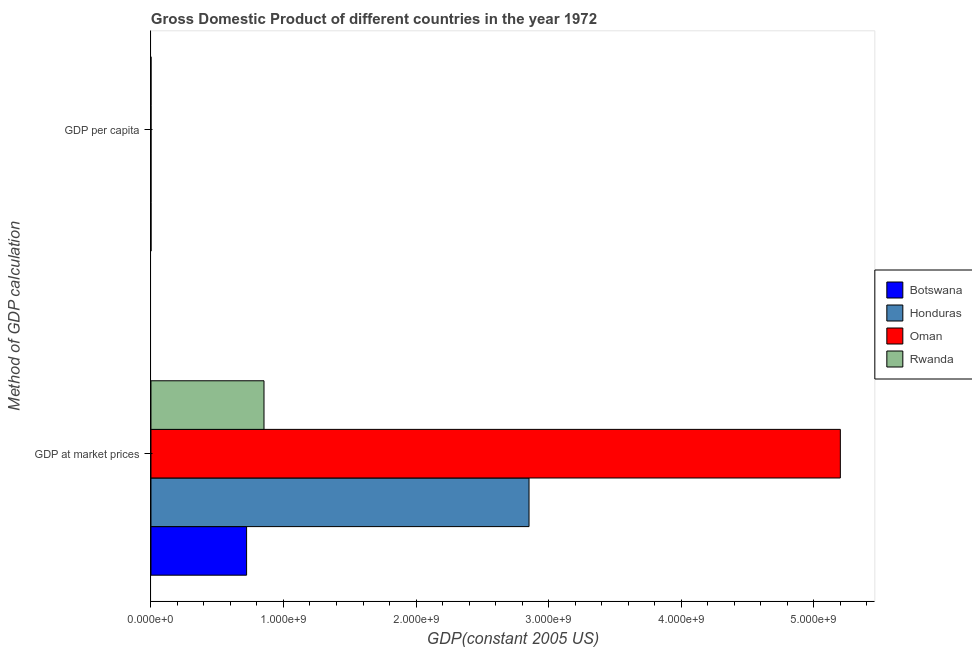How many groups of bars are there?
Offer a terse response. 2. How many bars are there on the 2nd tick from the top?
Provide a succinct answer. 4. How many bars are there on the 2nd tick from the bottom?
Keep it short and to the point. 4. What is the label of the 1st group of bars from the top?
Keep it short and to the point. GDP per capita. What is the gdp per capita in Rwanda?
Keep it short and to the point. 214.11. Across all countries, what is the maximum gdp per capita?
Offer a terse response. 6700.51. Across all countries, what is the minimum gdp at market prices?
Provide a short and direct response. 7.22e+08. In which country was the gdp at market prices maximum?
Keep it short and to the point. Oman. In which country was the gdp at market prices minimum?
Your answer should be compact. Botswana. What is the total gdp per capita in the graph?
Your response must be concise. 8892.82. What is the difference between the gdp per capita in Oman and that in Botswana?
Give a very brief answer. 5724.99. What is the difference between the gdp at market prices in Rwanda and the gdp per capita in Botswana?
Keep it short and to the point. 8.53e+08. What is the average gdp at market prices per country?
Keep it short and to the point. 2.41e+09. What is the difference between the gdp per capita and gdp at market prices in Rwanda?
Offer a terse response. -8.53e+08. What is the ratio of the gdp at market prices in Botswana to that in Honduras?
Provide a succinct answer. 0.25. What does the 1st bar from the top in GDP per capita represents?
Ensure brevity in your answer.  Rwanda. What does the 3rd bar from the bottom in GDP at market prices represents?
Offer a very short reply. Oman. How many bars are there?
Provide a succinct answer. 8. How many countries are there in the graph?
Your answer should be very brief. 4. What is the difference between two consecutive major ticks on the X-axis?
Ensure brevity in your answer.  1.00e+09. Does the graph contain any zero values?
Provide a succinct answer. No. Does the graph contain grids?
Your answer should be very brief. No. Where does the legend appear in the graph?
Provide a short and direct response. Center right. What is the title of the graph?
Offer a very short reply. Gross Domestic Product of different countries in the year 1972. What is the label or title of the X-axis?
Ensure brevity in your answer.  GDP(constant 2005 US). What is the label or title of the Y-axis?
Your response must be concise. Method of GDP calculation. What is the GDP(constant 2005 US) in Botswana in GDP at market prices?
Offer a very short reply. 7.22e+08. What is the GDP(constant 2005 US) of Honduras in GDP at market prices?
Provide a short and direct response. 2.85e+09. What is the GDP(constant 2005 US) of Oman in GDP at market prices?
Ensure brevity in your answer.  5.20e+09. What is the GDP(constant 2005 US) in Rwanda in GDP at market prices?
Your answer should be very brief. 8.53e+08. What is the GDP(constant 2005 US) in Botswana in GDP per capita?
Your response must be concise. 975.53. What is the GDP(constant 2005 US) in Honduras in GDP per capita?
Make the answer very short. 1002.68. What is the GDP(constant 2005 US) of Oman in GDP per capita?
Make the answer very short. 6700.51. What is the GDP(constant 2005 US) in Rwanda in GDP per capita?
Make the answer very short. 214.11. Across all Method of GDP calculation, what is the maximum GDP(constant 2005 US) of Botswana?
Your response must be concise. 7.22e+08. Across all Method of GDP calculation, what is the maximum GDP(constant 2005 US) of Honduras?
Your response must be concise. 2.85e+09. Across all Method of GDP calculation, what is the maximum GDP(constant 2005 US) in Oman?
Your answer should be compact. 5.20e+09. Across all Method of GDP calculation, what is the maximum GDP(constant 2005 US) in Rwanda?
Make the answer very short. 8.53e+08. Across all Method of GDP calculation, what is the minimum GDP(constant 2005 US) in Botswana?
Your response must be concise. 975.53. Across all Method of GDP calculation, what is the minimum GDP(constant 2005 US) in Honduras?
Your answer should be very brief. 1002.68. Across all Method of GDP calculation, what is the minimum GDP(constant 2005 US) in Oman?
Ensure brevity in your answer.  6700.51. Across all Method of GDP calculation, what is the minimum GDP(constant 2005 US) in Rwanda?
Provide a short and direct response. 214.11. What is the total GDP(constant 2005 US) of Botswana in the graph?
Give a very brief answer. 7.22e+08. What is the total GDP(constant 2005 US) of Honduras in the graph?
Ensure brevity in your answer.  2.85e+09. What is the total GDP(constant 2005 US) of Oman in the graph?
Make the answer very short. 5.20e+09. What is the total GDP(constant 2005 US) in Rwanda in the graph?
Your answer should be compact. 8.53e+08. What is the difference between the GDP(constant 2005 US) of Botswana in GDP at market prices and that in GDP per capita?
Your answer should be compact. 7.22e+08. What is the difference between the GDP(constant 2005 US) in Honduras in GDP at market prices and that in GDP per capita?
Give a very brief answer. 2.85e+09. What is the difference between the GDP(constant 2005 US) of Oman in GDP at market prices and that in GDP per capita?
Provide a short and direct response. 5.20e+09. What is the difference between the GDP(constant 2005 US) of Rwanda in GDP at market prices and that in GDP per capita?
Keep it short and to the point. 8.53e+08. What is the difference between the GDP(constant 2005 US) in Botswana in GDP at market prices and the GDP(constant 2005 US) in Honduras in GDP per capita?
Your answer should be compact. 7.22e+08. What is the difference between the GDP(constant 2005 US) of Botswana in GDP at market prices and the GDP(constant 2005 US) of Oman in GDP per capita?
Keep it short and to the point. 7.22e+08. What is the difference between the GDP(constant 2005 US) in Botswana in GDP at market prices and the GDP(constant 2005 US) in Rwanda in GDP per capita?
Give a very brief answer. 7.22e+08. What is the difference between the GDP(constant 2005 US) of Honduras in GDP at market prices and the GDP(constant 2005 US) of Oman in GDP per capita?
Offer a terse response. 2.85e+09. What is the difference between the GDP(constant 2005 US) of Honduras in GDP at market prices and the GDP(constant 2005 US) of Rwanda in GDP per capita?
Offer a very short reply. 2.85e+09. What is the difference between the GDP(constant 2005 US) of Oman in GDP at market prices and the GDP(constant 2005 US) of Rwanda in GDP per capita?
Your response must be concise. 5.20e+09. What is the average GDP(constant 2005 US) of Botswana per Method of GDP calculation?
Offer a terse response. 3.61e+08. What is the average GDP(constant 2005 US) in Honduras per Method of GDP calculation?
Your response must be concise. 1.43e+09. What is the average GDP(constant 2005 US) of Oman per Method of GDP calculation?
Offer a very short reply. 2.60e+09. What is the average GDP(constant 2005 US) in Rwanda per Method of GDP calculation?
Your answer should be compact. 4.26e+08. What is the difference between the GDP(constant 2005 US) of Botswana and GDP(constant 2005 US) of Honduras in GDP at market prices?
Make the answer very short. -2.13e+09. What is the difference between the GDP(constant 2005 US) of Botswana and GDP(constant 2005 US) of Oman in GDP at market prices?
Your answer should be compact. -4.48e+09. What is the difference between the GDP(constant 2005 US) in Botswana and GDP(constant 2005 US) in Rwanda in GDP at market prices?
Ensure brevity in your answer.  -1.31e+08. What is the difference between the GDP(constant 2005 US) of Honduras and GDP(constant 2005 US) of Oman in GDP at market prices?
Offer a terse response. -2.35e+09. What is the difference between the GDP(constant 2005 US) of Honduras and GDP(constant 2005 US) of Rwanda in GDP at market prices?
Provide a short and direct response. 2.00e+09. What is the difference between the GDP(constant 2005 US) in Oman and GDP(constant 2005 US) in Rwanda in GDP at market prices?
Make the answer very short. 4.35e+09. What is the difference between the GDP(constant 2005 US) in Botswana and GDP(constant 2005 US) in Honduras in GDP per capita?
Provide a short and direct response. -27.15. What is the difference between the GDP(constant 2005 US) in Botswana and GDP(constant 2005 US) in Oman in GDP per capita?
Your response must be concise. -5724.99. What is the difference between the GDP(constant 2005 US) of Botswana and GDP(constant 2005 US) of Rwanda in GDP per capita?
Your response must be concise. 761.42. What is the difference between the GDP(constant 2005 US) of Honduras and GDP(constant 2005 US) of Oman in GDP per capita?
Give a very brief answer. -5697.84. What is the difference between the GDP(constant 2005 US) in Honduras and GDP(constant 2005 US) in Rwanda in GDP per capita?
Keep it short and to the point. 788.57. What is the difference between the GDP(constant 2005 US) of Oman and GDP(constant 2005 US) of Rwanda in GDP per capita?
Your answer should be very brief. 6486.4. What is the ratio of the GDP(constant 2005 US) in Botswana in GDP at market prices to that in GDP per capita?
Ensure brevity in your answer.  7.40e+05. What is the ratio of the GDP(constant 2005 US) in Honduras in GDP at market prices to that in GDP per capita?
Your response must be concise. 2.85e+06. What is the ratio of the GDP(constant 2005 US) in Oman in GDP at market prices to that in GDP per capita?
Your response must be concise. 7.76e+05. What is the ratio of the GDP(constant 2005 US) in Rwanda in GDP at market prices to that in GDP per capita?
Make the answer very short. 3.98e+06. What is the difference between the highest and the second highest GDP(constant 2005 US) of Botswana?
Ensure brevity in your answer.  7.22e+08. What is the difference between the highest and the second highest GDP(constant 2005 US) of Honduras?
Keep it short and to the point. 2.85e+09. What is the difference between the highest and the second highest GDP(constant 2005 US) in Oman?
Make the answer very short. 5.20e+09. What is the difference between the highest and the second highest GDP(constant 2005 US) in Rwanda?
Keep it short and to the point. 8.53e+08. What is the difference between the highest and the lowest GDP(constant 2005 US) of Botswana?
Provide a succinct answer. 7.22e+08. What is the difference between the highest and the lowest GDP(constant 2005 US) in Honduras?
Your answer should be compact. 2.85e+09. What is the difference between the highest and the lowest GDP(constant 2005 US) in Oman?
Your answer should be compact. 5.20e+09. What is the difference between the highest and the lowest GDP(constant 2005 US) of Rwanda?
Provide a succinct answer. 8.53e+08. 